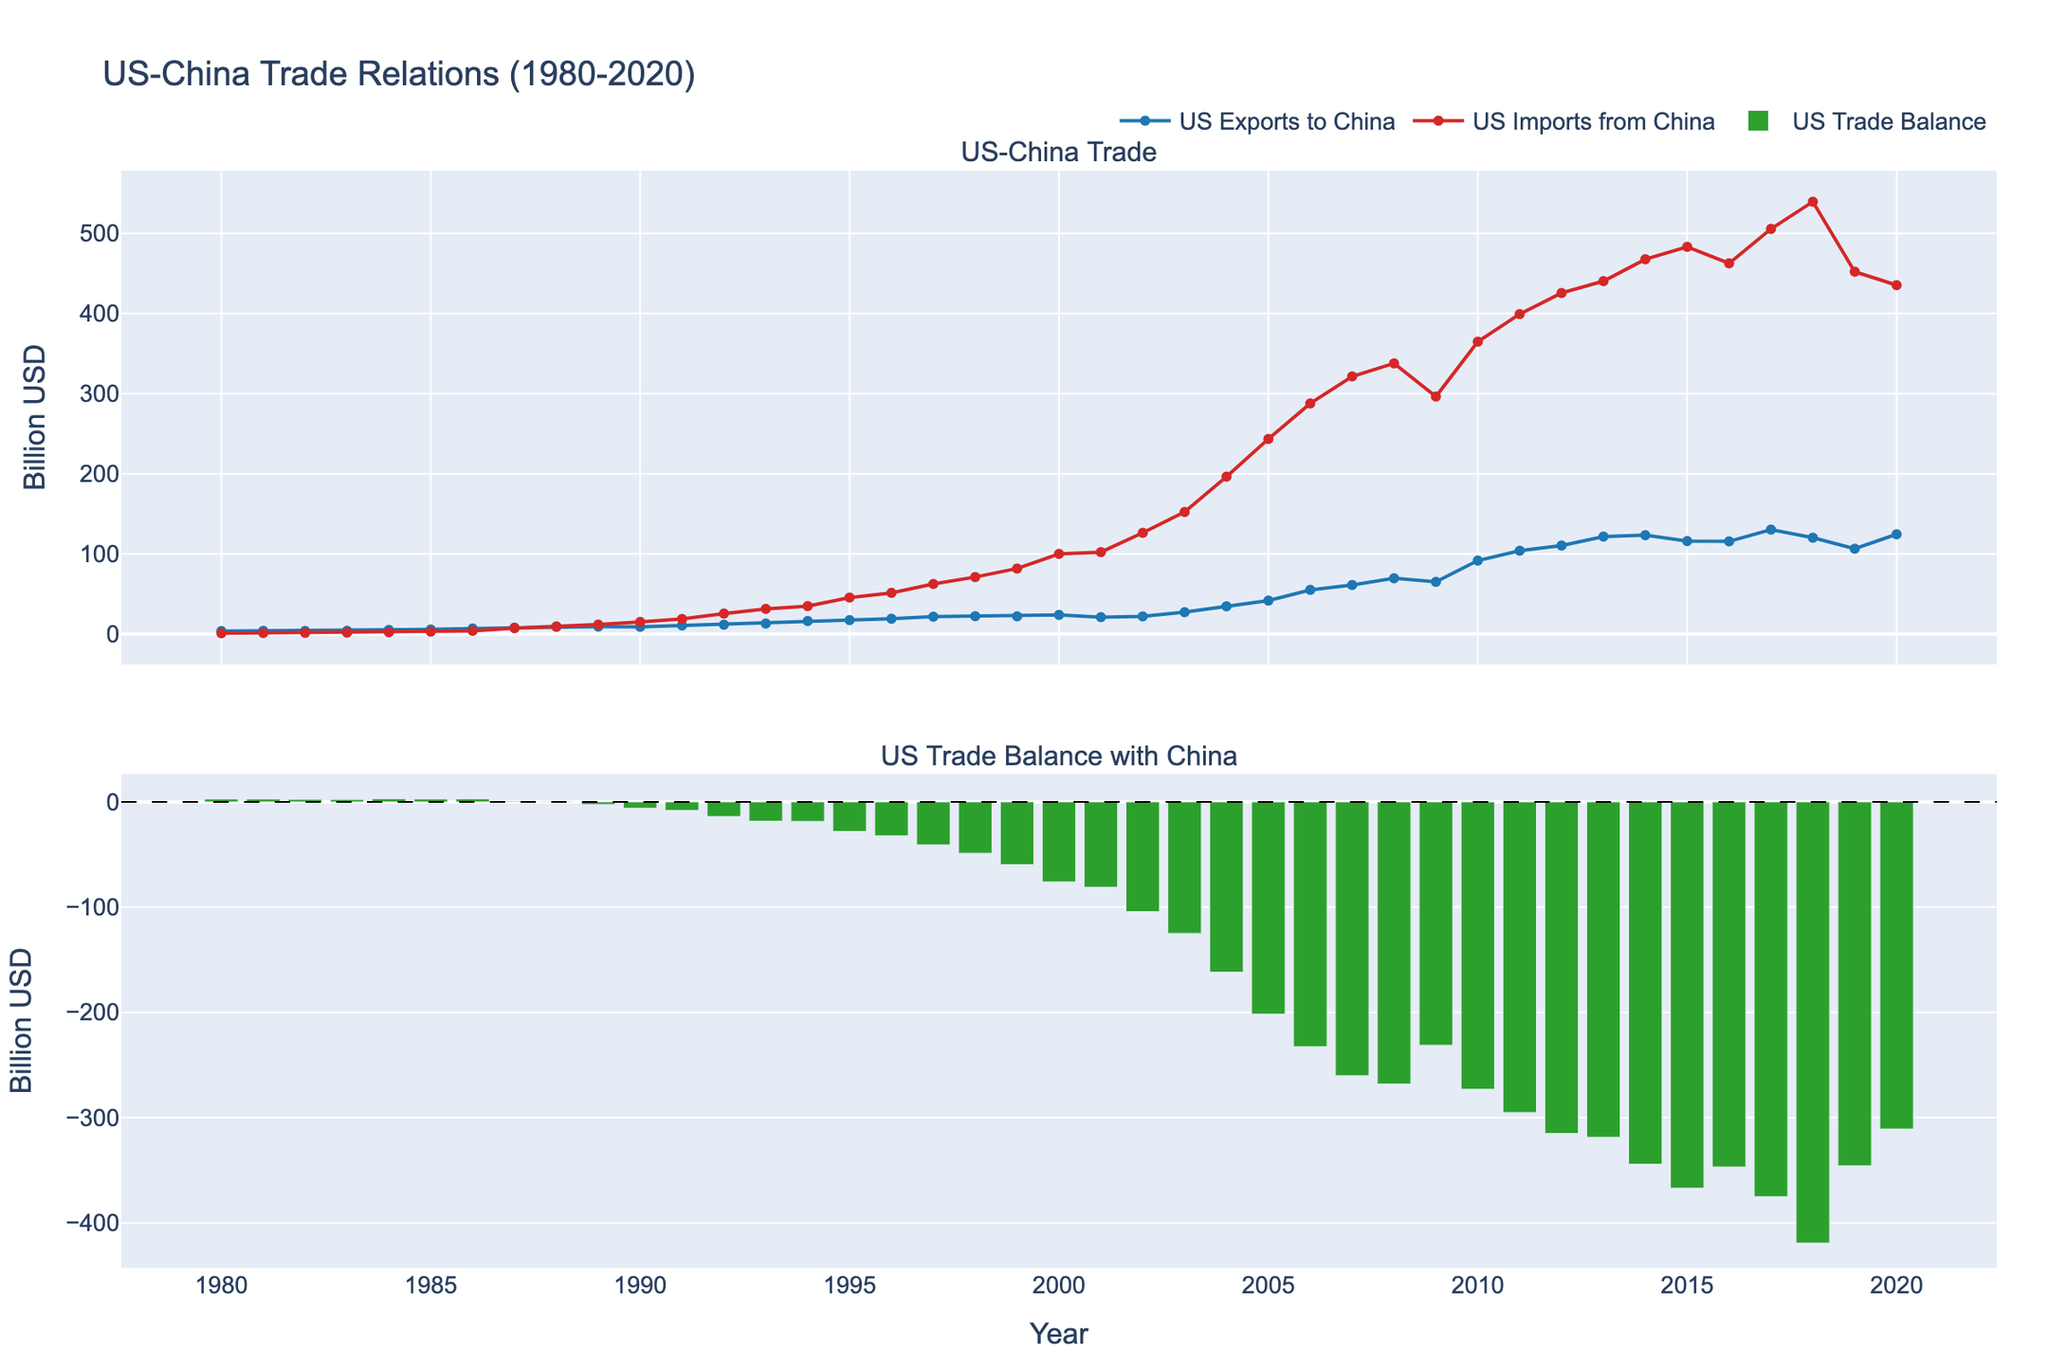What is the overall trend of US exports to China from 1980 to 2020? The figure shows a time series plot with US exports to China steadily increasing from 1980 until around 2014, with minor fluctuations starting from 2015 to 2020. This indicates a general upward trend over the entire period.
Answer: Steady increase with fluctuations from 2015 onward What is the largest trade balance deficit observed between the US and China? By looking at the bar plot representing the US trade balance, the highest negative bar indicates the largest deficit, which occurred in 2018. The value of the deficit in 2018 is -419.2 billion USD.
Answer: -419.2 billion USD How do US exports to China compare to US imports from China in 1989? In the year 1989, the time series plot shows US exports to China at approximately 9.4 billion USD and US imports from China at approximately 11.9 billion USD. Comparing these values, imports were higher than exports in 1989.
Answer: Imports were higher than exports During which years did the US experience a trade surplus with China? A trade surplus occurs when the trade balance is positive. By examining the bar plot, only the years 1980 to 1988 show positive bars, indicating trade surpluses.
Answer: 1980 to 1988 What is the trend in the US trade balance with China from 2000 to 2020? From 2000 to 2020, the bar plot shows a consistent negative trend, with the trade balance deficit widening significantly during this period, indicating an increasing trade deficit overall.
Answer: Increasing trade deficit What was the difference between US exports to China and imports from China in 1995? The plot shows US exports to China were approximately 17.5 billion USD in 1995, and imports from China were about 45.6 billion USD. The difference can be calculated as 45.6 - 17.5 = 28.1 billion USD.
Answer: 28.1 billion USD What is the relationship between US exports to China and US trade balance from 1980 to 2020? The trade balance is calculated as exports minus imports. From 1980 to 2020, as exports increased, the trade balance remained negative due to imports increasing at a faster rate, leading to a growing trade deficit despite higher exports.
Answer: Growing trade deficit due to faster-growing imports Which year shows the highest US exports to China, and what is the value? By examining the peak in the time series plot for US exports, the highest point occurs in 2014, with a value of approximately 123.4 billion USD.
Answer: 2014, 123.4 billion USD Which period shows the fastest growth in US imports from China? The time series for US imports increases steeply between 2000 and 2005, indicating this period as the fastest growth in imports from China.
Answer: 2000-2005 How did US exports to China and imports from China change between 2009 and 2010? Between 2009 and 2010, the plot indicates US exports to China increased from 65.2 billion USD to 91.8 billion USD, while imports increased from 296.4 billion USD to 364.9 billion USD. Both exports and imports saw significant growth.
Answer: Both increased significantly 